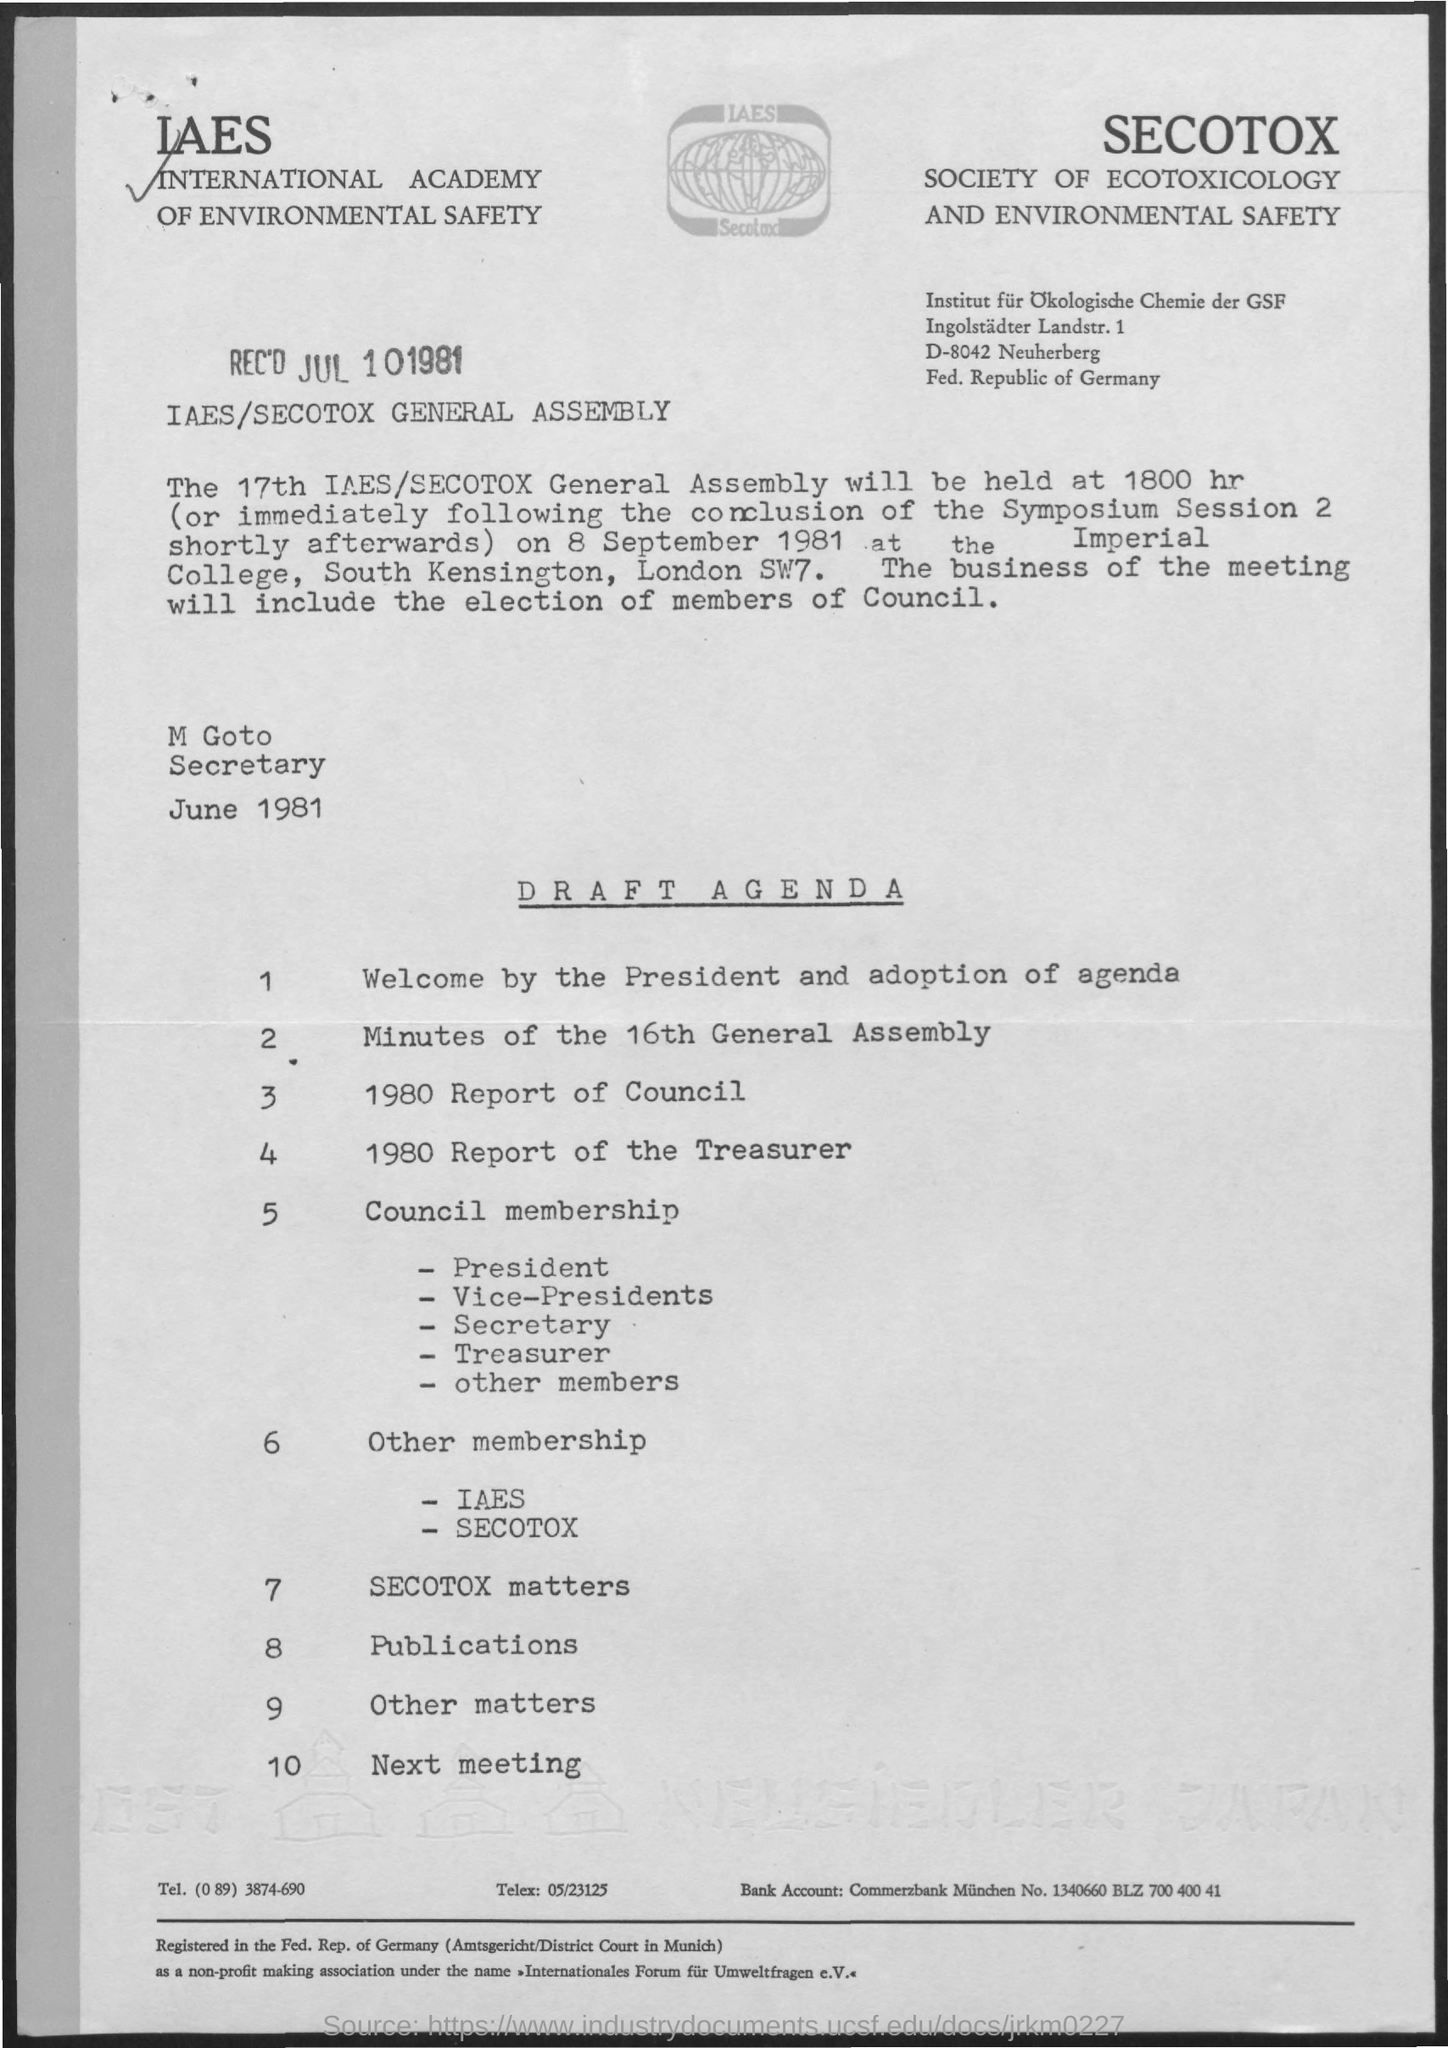What is the number of agenda connected with "Other Matters"
Offer a terse response. 9. What is 3rd Agenda?
Offer a terse response. 1980 report of council. How many agendas are there in agenda notice?
Offer a terse response. 10. What is the date of general assembly?
Your response must be concise. 8 september 1981. 